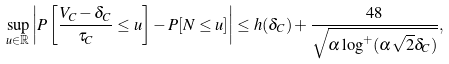Convert formula to latex. <formula><loc_0><loc_0><loc_500><loc_500>\sup _ { u \in \mathbb { R } } \left | P \left [ \frac { V _ { C } - \delta _ { C } } { \tau _ { C } } \leq u \right ] - P [ N \leq u ] \right | \leq h ( \delta _ { C } ) + \frac { 4 8 } { \sqrt { \alpha \log ^ { + } ( \alpha \sqrt { 2 } \delta _ { C } ) } } ,</formula> 